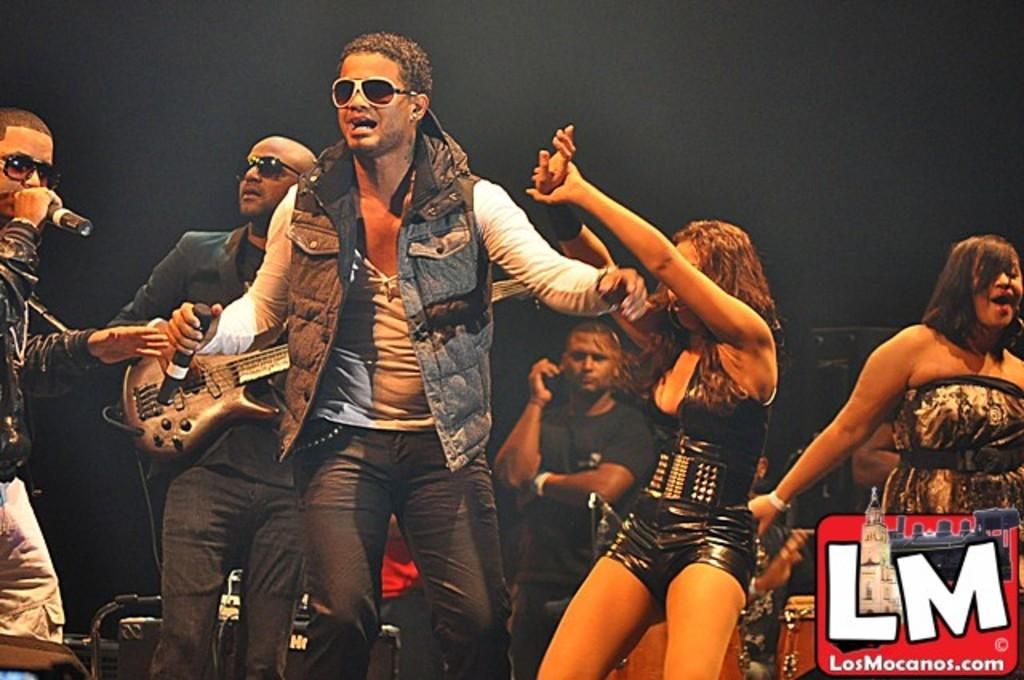What are the people in the image doing? There are persons on the floor, and one person is playing a guitar. What else is the person with the guitar doing? The person playing the guitar is also singing on a microphone. Can you describe any accessories the person with the guitar is wearing? The person playing the guitar has goggles. What type of underwear is the scarecrow wearing in the image? There is no scarecrow present in the image, and therefore no underwear can be observed. 